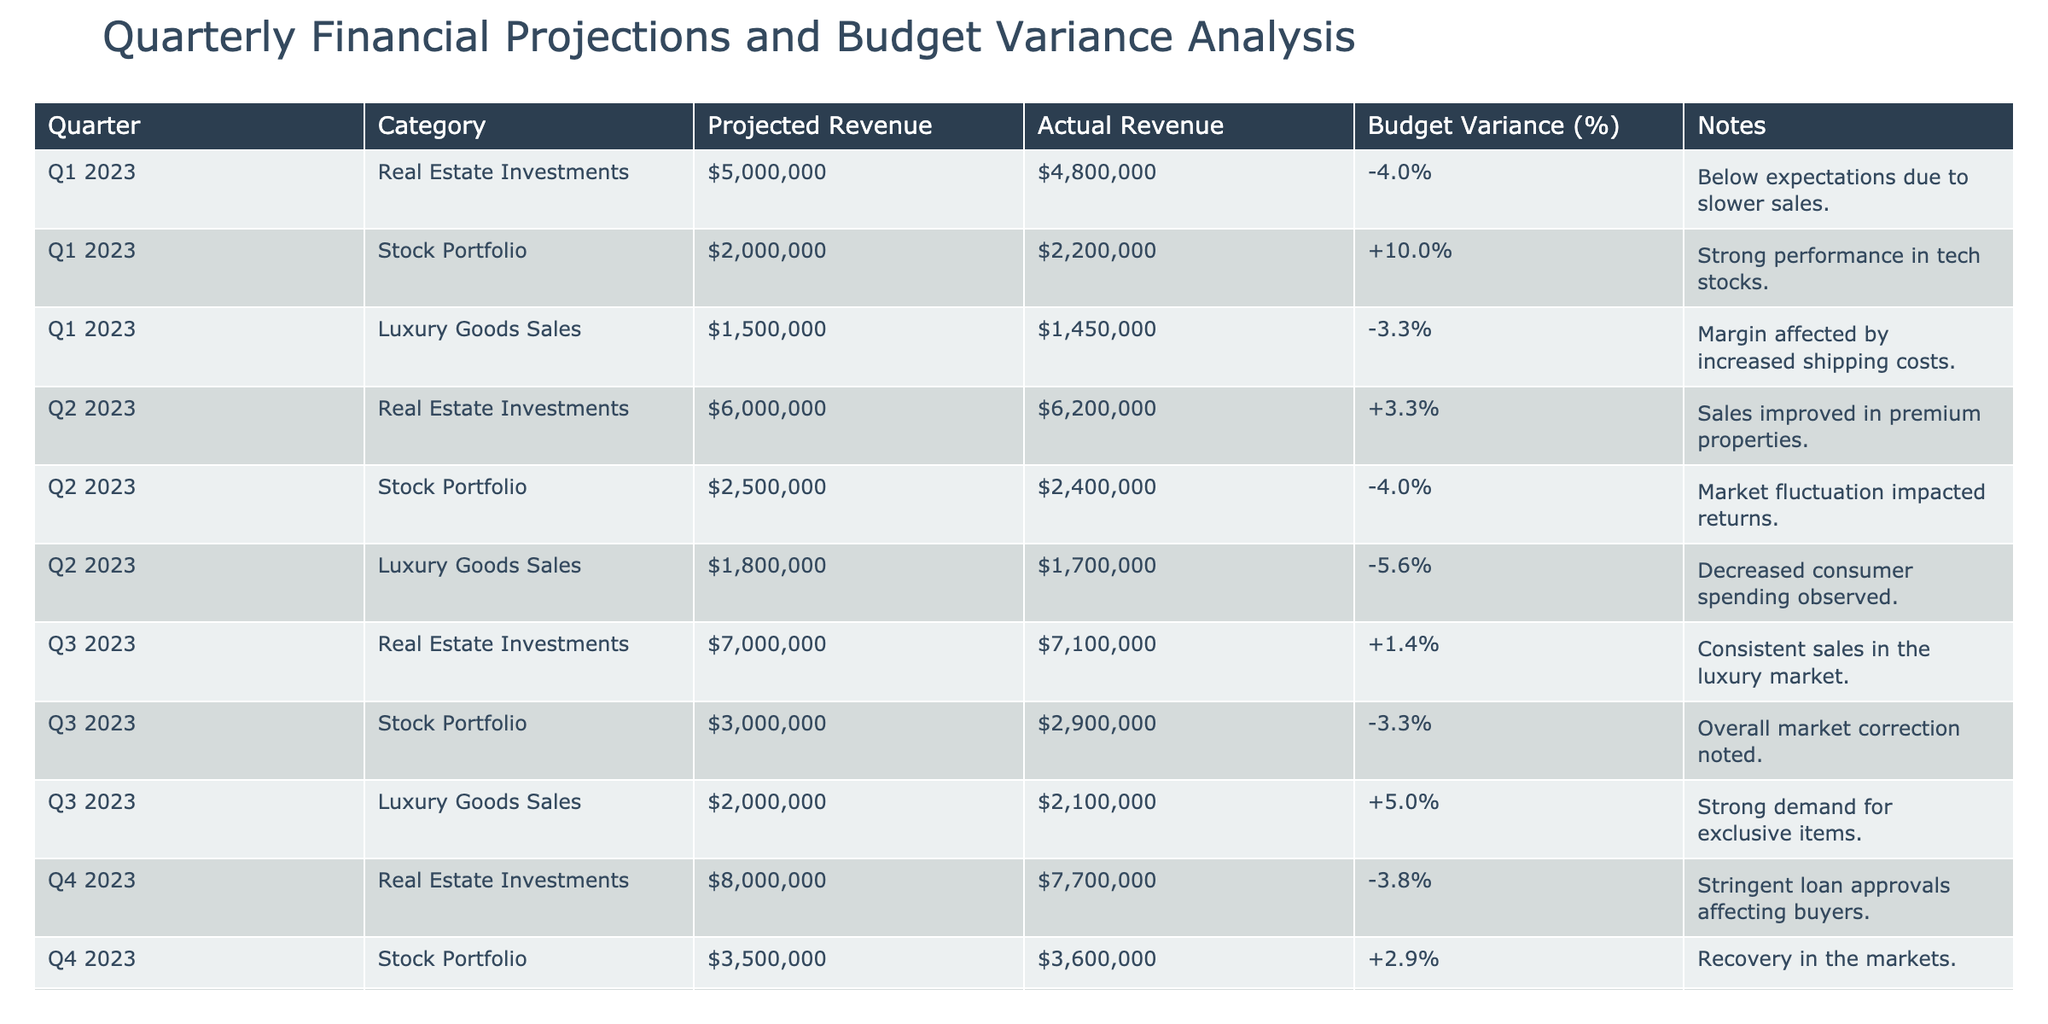What was the budget variance percentage for Luxury Goods Sales in Q1 2023? The table shows that the budget variance for Luxury Goods Sales in Q1 2023 is -3.3%.
Answer: -3.3% In which quarter did Stock Portfolio have the highest actual revenue? By examining the rows for Stock Portfolio, Q4 2023 shows the highest actual revenue at $3,600,000.
Answer: Q4 2023 What is the total projected revenue for Real Estate Investments across all quarters? The projected revenue for Real Estate Investments is $5,000,000 (Q1) + $6,000,000 (Q2) + $7,000,000 (Q3) + $8,000,000 (Q4) = $26,000,000.
Answer: $26,000,000 Did Luxury Goods Sales perform better than their projections in Q3 2023? In Q3 2023, the actual revenue for Luxury Goods Sales was $2,100,000, which is above the projected revenue of $2,000,000. Therefore, they performed better than their projections.
Answer: Yes What is the average budget variance percentage for Stock Portfolio across all quarters? The budget variance percentages for Stock Portfolio are +10.0% (Q1), -4.0% (Q2), -3.3% (Q3), and +2.9% (Q4). The average is calculated as (10.0 - 4.0 - 3.3 + 2.9) / 4 = 1.4 / 4 = 0.35%.
Answer: 0.35% Which category had the lowest actual revenue in Q2 2023? Reviewing Q2 2023 data, Luxury Goods Sales had the lowest actual revenue at $1,700,000 compared to Real Estate Investments at $6,200,000 and Stock Portfolio at $2,400,000.
Answer: Luxury Goods Sales Was there a consistent upward trend in projected revenue for Real Estate Investments from Q1 2023 to Q4 2023? The projected revenues for Real Estate Investments were $5,000,000 in Q1, $6,000,000 in Q2, $7,000,000 in Q3, and $8,000,000 in Q4, indicating a consistent upward trend throughout the quarters.
Answer: Yes What was the deviation in actual revenue for Real Estate Investments from Q4 2023 against its projection? In Q4 2023, the projected revenue for Real Estate Investments was $8,000,000, while the actual revenue was $7,700,000, leading to a deviation of $8,000,000 - $7,700,000 = $300,000.
Answer: $300,000 Which quarter exhibited the largest budget variance for Stock Portfolio? By examining the table, Q1 2023 shows the largest positive budget variance of +10.0% for Stock Portfolio when compared to other quarters.
Answer: Q1 2023 What was the cumulative actual revenue for Luxury Goods Sales over all quarters? The actual revenues for Luxury Goods Sales across all quarters are $1,450,000 (Q1) + $1,700,000 (Q2) + $2,100,000 (Q3) + $2,400,000 (Q4) = $7,650,000.
Answer: $7,650,000 